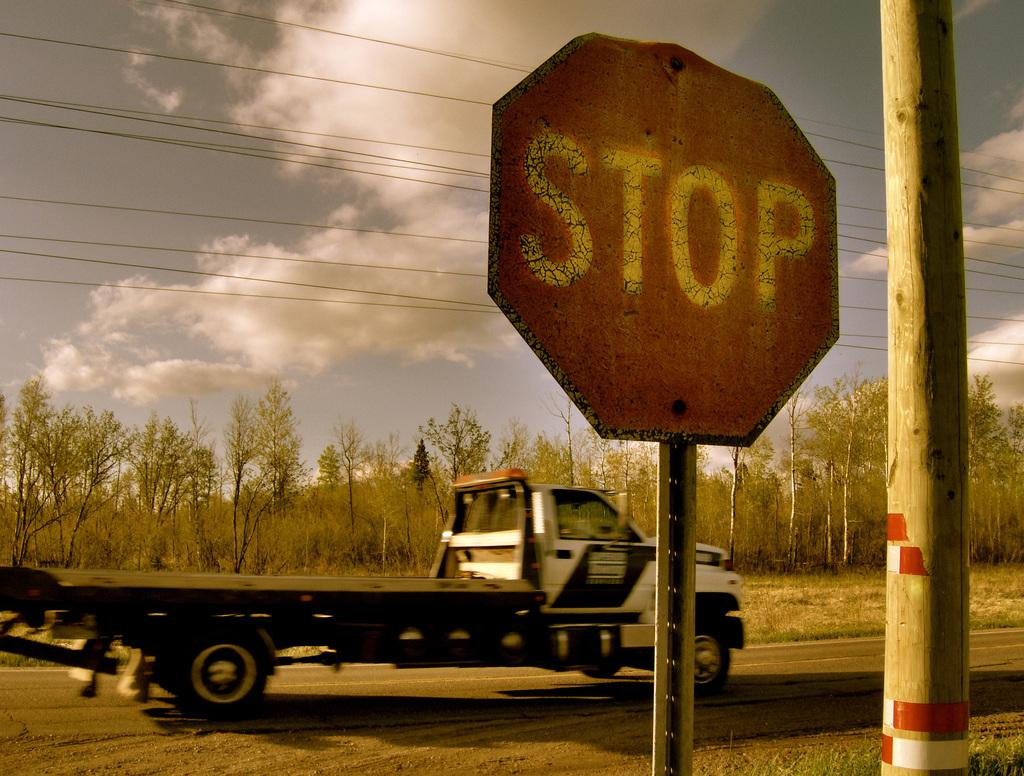<image>
Write a terse but informative summary of the picture. Beside a wooden telephone pole a stop sign stands in plain site. 